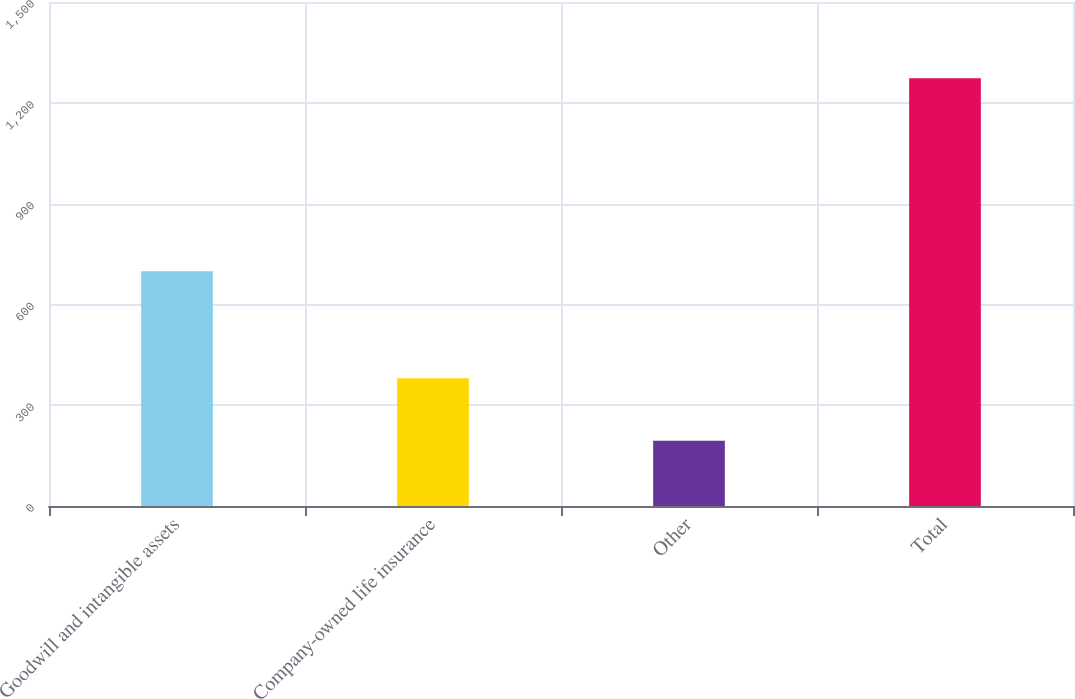Convert chart to OTSL. <chart><loc_0><loc_0><loc_500><loc_500><bar_chart><fcel>Goodwill and intangible assets<fcel>Company-owned life insurance<fcel>Other<fcel>Total<nl><fcel>699<fcel>380<fcel>194<fcel>1273<nl></chart> 